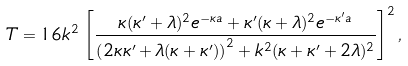Convert formula to latex. <formula><loc_0><loc_0><loc_500><loc_500>T = 1 6 k ^ { 2 } \, \left [ \frac { \kappa ( \kappa ^ { \prime } + \lambda ) ^ { 2 } e ^ { - \kappa a } + \kappa ^ { \prime } ( \kappa + \lambda ) ^ { 2 } e ^ { - \kappa ^ { \prime } a } } { \left ( 2 \kappa \kappa ^ { \prime } + \lambda ( \kappa + \kappa ^ { \prime } ) \right ) ^ { 2 } + k ^ { 2 } ( \kappa + \kappa ^ { \prime } + 2 \lambda ) ^ { 2 } } \right ] ^ { 2 } ,</formula> 